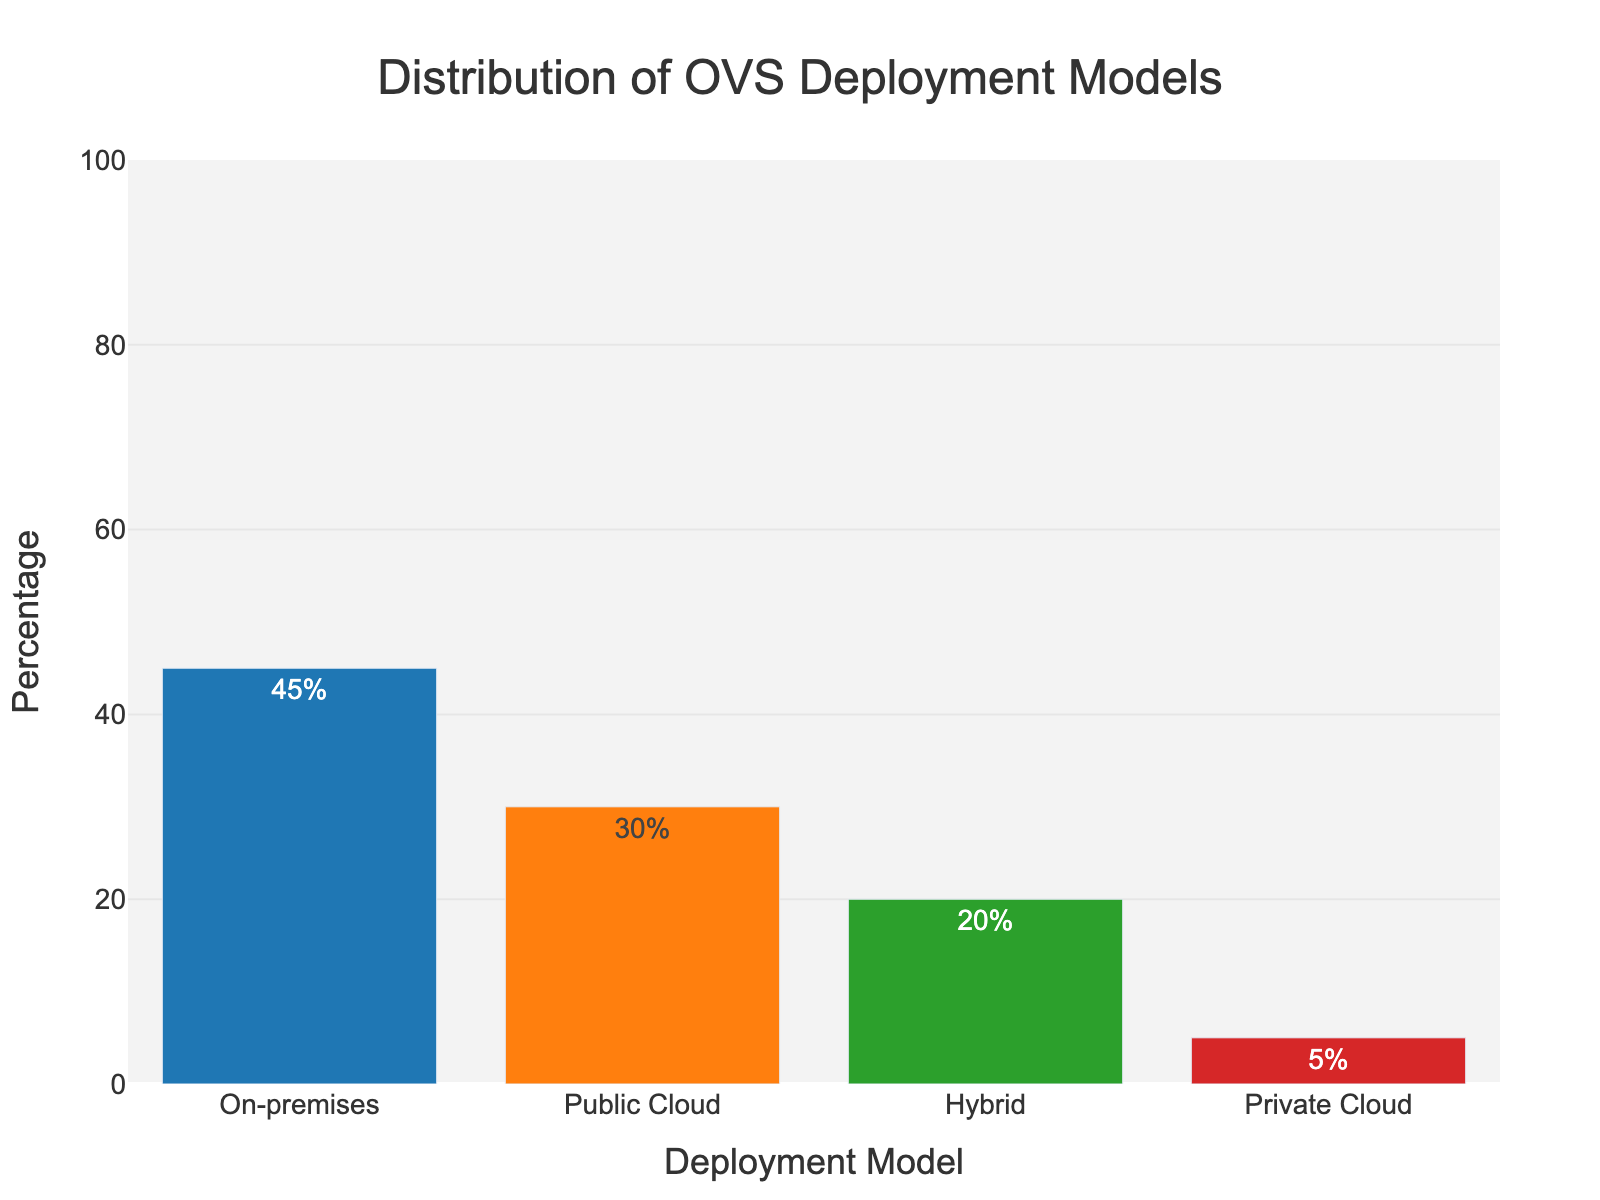Which deployment model has the highest percentage? The figure shows a bar chart with each bar representing the percentage of deployment models. The "On-premises" bar is the tallest, indicating that it has the highest percentage.
Answer: On-premises Which deployment model has the lowest percentage? From the bar chart, the "Private Cloud" bar is the shortest, indicating that it has the lowest percentage.
Answer: Private Cloud What is the total percentage of enterprises using cloud-based solutions (public or private)? To find the total percentage of cloud-based solutions, you need to sum the percentages of "Public Cloud" (30%) and "Private Cloud" (5%).
Answer: 35% What is the combined percentage of enterprises using on-premises and hybrid models? Sum the percentages of "On-premises" (45%) and "Hybrid" (20%). 45% + 20% = 65%.
Answer: 65% How does the percentage of enterprises using hybrid models compare to those using private cloud? The percentage for hybrid models (20%) is higher than that for private cloud (5%). 20% > 5%.
Answer: Hybrid models have a higher percentage What is the difference between the highest and lowest deployment model percentages? Subtract the lowest percentage (Private Cloud, 5%) from the highest percentage (On-premises, 45%). 45% - 5% = 40%.
Answer: 40% If 1000 enterprises were surveyed, how many are using the public cloud model? To find the number of enterprises, multiply the total number by the percentage for public cloud. 1000 enterprises * 30% = 300 enterprises.
Answer: 300 enterprises Which deployment model has the second-highest percentage? By looking at the heights of the bars, the "Public Cloud" has the second-highest percentage after "On-premises".
Answer: Public Cloud What is the difference in percentage between hybrid and public cloud models? Subtract the percentage of hybrid (20%) from the public cloud (30%). 30% - 20% = 10%.
Answer: 10% What percentage of enterprises prefer deployment models other than on-premises? Subtract the percentage of On-premises (45%) from the total (100%). 100% - 45% = 55%.
Answer: 55% 